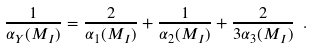Convert formula to latex. <formula><loc_0><loc_0><loc_500><loc_500>\frac { 1 } { \alpha _ { Y } ( M _ { I } ) } = \frac { 2 } { \alpha _ { 1 } ( M _ { I } ) } + \frac { 1 } { \alpha _ { 2 } ( M _ { I } ) } + \frac { 2 } { 3 \alpha _ { 3 } ( M _ { I } ) } \ .</formula> 